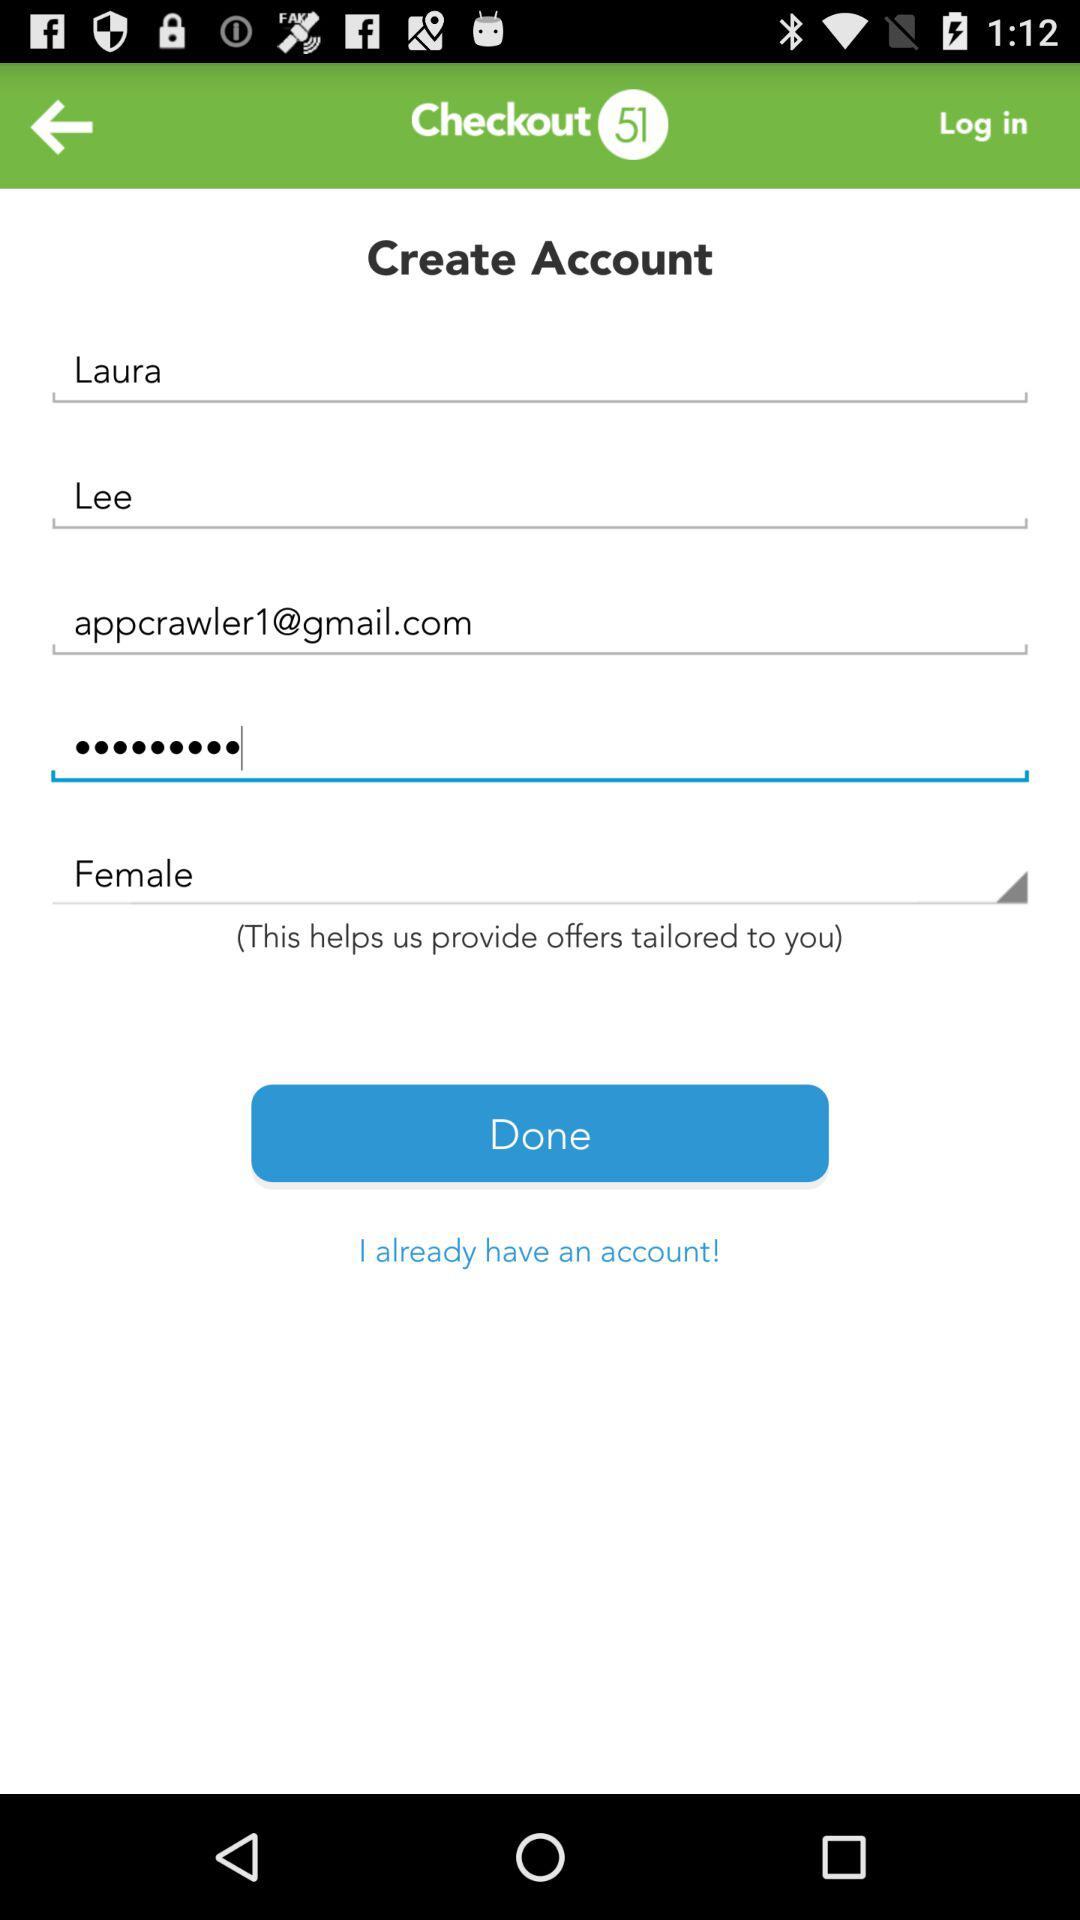What is the Gmail ID? The Gmail ID is appcrawler1@gmail.com. 